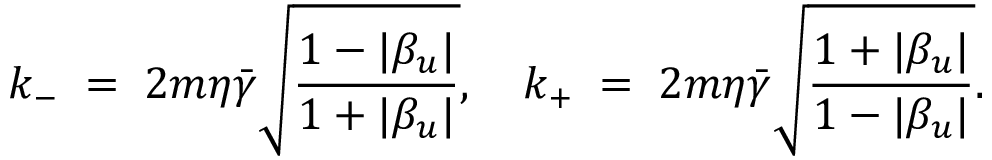Convert formula to latex. <formula><loc_0><loc_0><loc_500><loc_500>k _ { - } \, = \, 2 m \eta \bar { \gamma } \sqrt { { \frac { 1 - | \beta _ { u } | } { 1 + | \beta _ { u } | } } } , \quad k _ { + } \, = \, 2 m \eta \bar { \gamma } \sqrt { { \frac { 1 + | \beta _ { u } | } { 1 - | \beta _ { u } | } } } .</formula> 